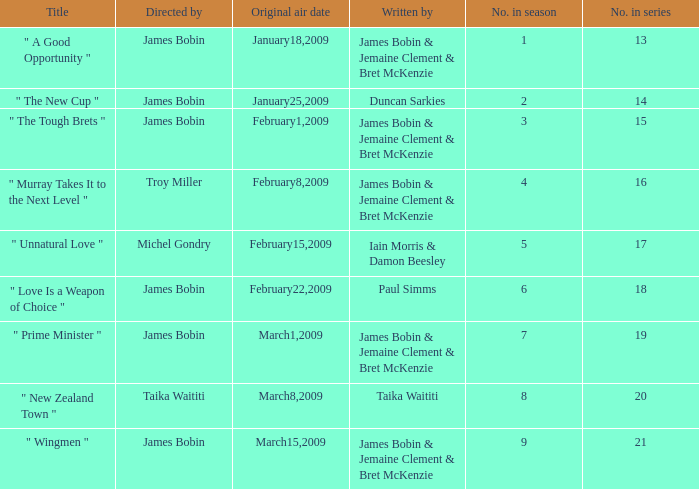 what's the title where original air date is january18,2009 " A Good Opportunity ". 